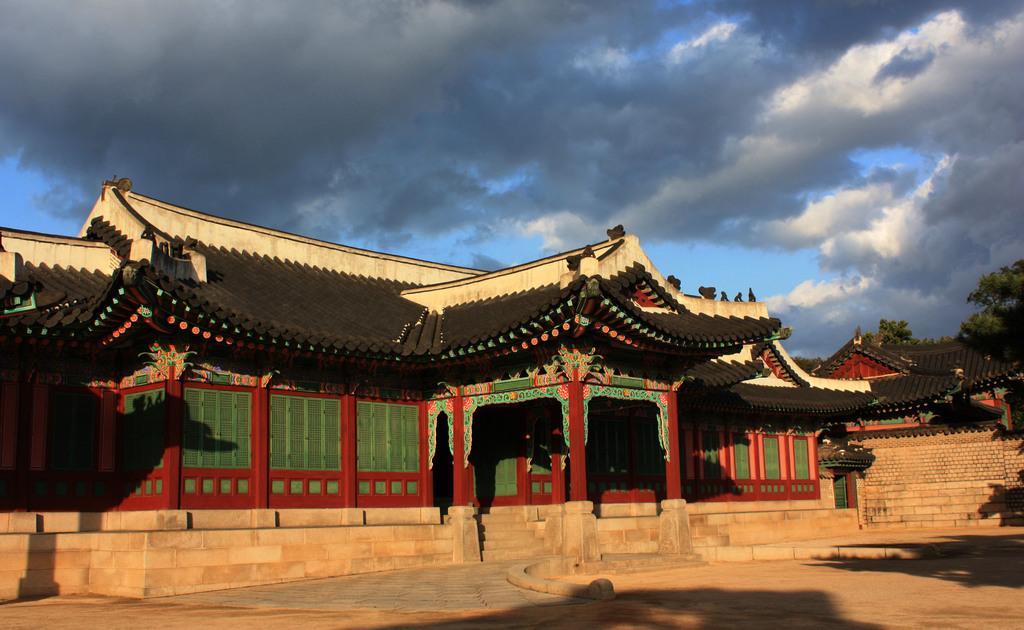Could you give a brief overview of what you see in this image? We can see houses and wall. On the background we can see trees and sky with clouds. 